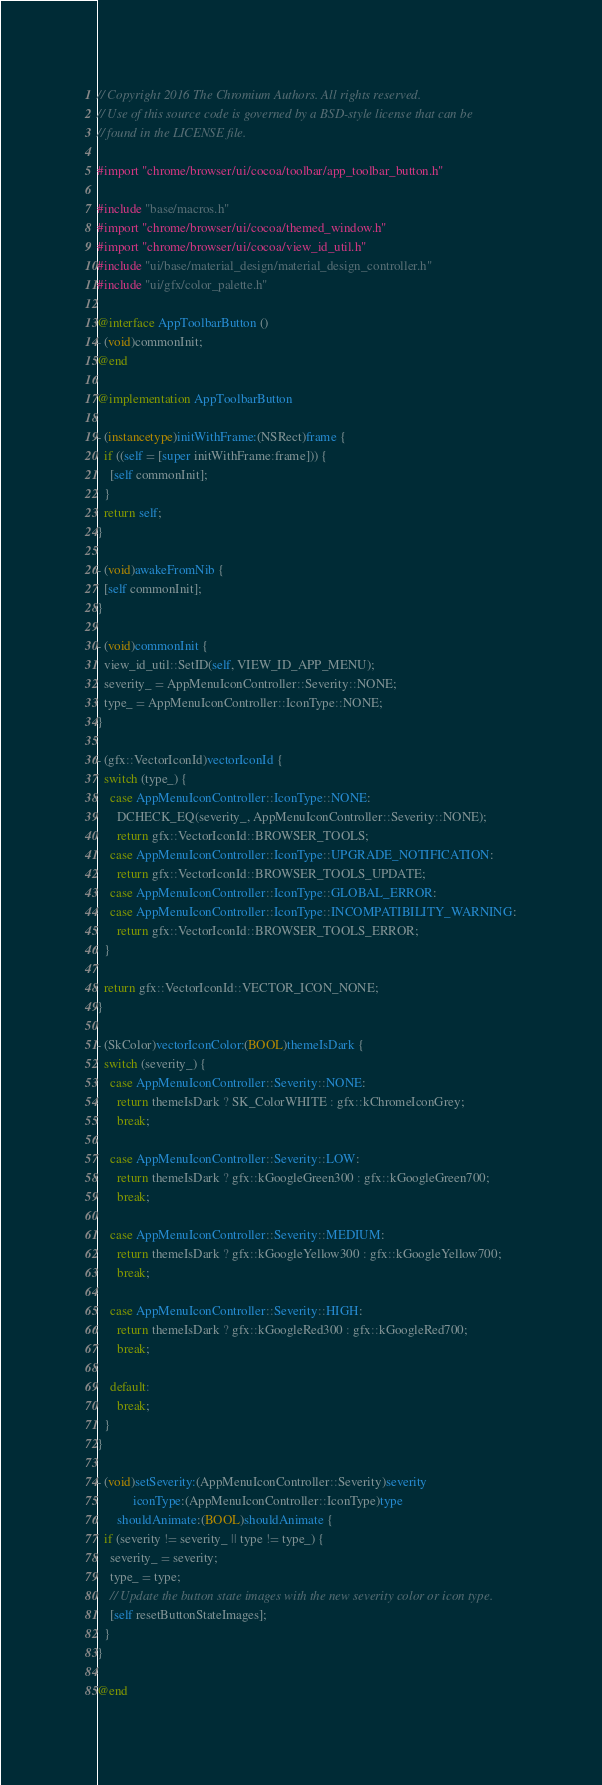<code> <loc_0><loc_0><loc_500><loc_500><_ObjectiveC_>// Copyright 2016 The Chromium Authors. All rights reserved.
// Use of this source code is governed by a BSD-style license that can be
// found in the LICENSE file.

#import "chrome/browser/ui/cocoa/toolbar/app_toolbar_button.h"

#include "base/macros.h"
#import "chrome/browser/ui/cocoa/themed_window.h"
#import "chrome/browser/ui/cocoa/view_id_util.h"
#include "ui/base/material_design/material_design_controller.h"
#include "ui/gfx/color_palette.h"

@interface AppToolbarButton ()
- (void)commonInit;
@end

@implementation AppToolbarButton

- (instancetype)initWithFrame:(NSRect)frame {
  if ((self = [super initWithFrame:frame])) {
    [self commonInit];
  }
  return self;
}

- (void)awakeFromNib {
  [self commonInit];
}

- (void)commonInit {
  view_id_util::SetID(self, VIEW_ID_APP_MENU);
  severity_ = AppMenuIconController::Severity::NONE;
  type_ = AppMenuIconController::IconType::NONE;
}

- (gfx::VectorIconId)vectorIconId {
  switch (type_) {
    case AppMenuIconController::IconType::NONE:
      DCHECK_EQ(severity_, AppMenuIconController::Severity::NONE);
      return gfx::VectorIconId::BROWSER_TOOLS;
    case AppMenuIconController::IconType::UPGRADE_NOTIFICATION:
      return gfx::VectorIconId::BROWSER_TOOLS_UPDATE;
    case AppMenuIconController::IconType::GLOBAL_ERROR:
    case AppMenuIconController::IconType::INCOMPATIBILITY_WARNING:
      return gfx::VectorIconId::BROWSER_TOOLS_ERROR;
  }

  return gfx::VectorIconId::VECTOR_ICON_NONE;
}

- (SkColor)vectorIconColor:(BOOL)themeIsDark {
  switch (severity_) {
    case AppMenuIconController::Severity::NONE:
      return themeIsDark ? SK_ColorWHITE : gfx::kChromeIconGrey;
      break;

    case AppMenuIconController::Severity::LOW:
      return themeIsDark ? gfx::kGoogleGreen300 : gfx::kGoogleGreen700;
      break;

    case AppMenuIconController::Severity::MEDIUM:
      return themeIsDark ? gfx::kGoogleYellow300 : gfx::kGoogleYellow700;
      break;

    case AppMenuIconController::Severity::HIGH:
      return themeIsDark ? gfx::kGoogleRed300 : gfx::kGoogleRed700;
      break;

    default:
      break;
  }
}

- (void)setSeverity:(AppMenuIconController::Severity)severity
           iconType:(AppMenuIconController::IconType)type
      shouldAnimate:(BOOL)shouldAnimate {
  if (severity != severity_ || type != type_) {
    severity_ = severity;
    type_ = type;
    // Update the button state images with the new severity color or icon type.
    [self resetButtonStateImages];
  }
}

@end
</code> 